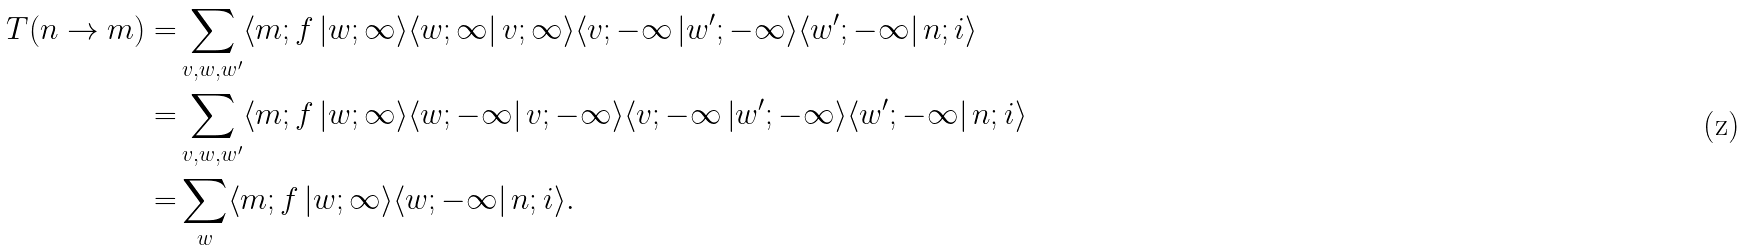Convert formula to latex. <formula><loc_0><loc_0><loc_500><loc_500>T ( n \rightarrow m ) = & \sum _ { v , w , w ^ { \prime } } \langle m ; f \left | w ; \infty \rangle \langle w ; \infty \right | v ; \infty \rangle \langle v ; - \infty \left | w ^ { \prime } ; - \infty \rangle \langle w ^ { \prime } ; - \infty \right | n ; i \rangle \\ = & \sum _ { v , w , w ^ { \prime } } \langle m ; f \left | w ; \infty \rangle \langle w ; - \infty \right | v ; - \infty \rangle \langle v ; - \infty \left | w ^ { \prime } ; - \infty \rangle \langle w ^ { \prime } ; - \infty \right | n ; i \rangle \\ = & \sum _ { w } \langle m ; f \left | w ; \infty \rangle \langle w ; - \infty \right | n ; i \rangle .</formula> 